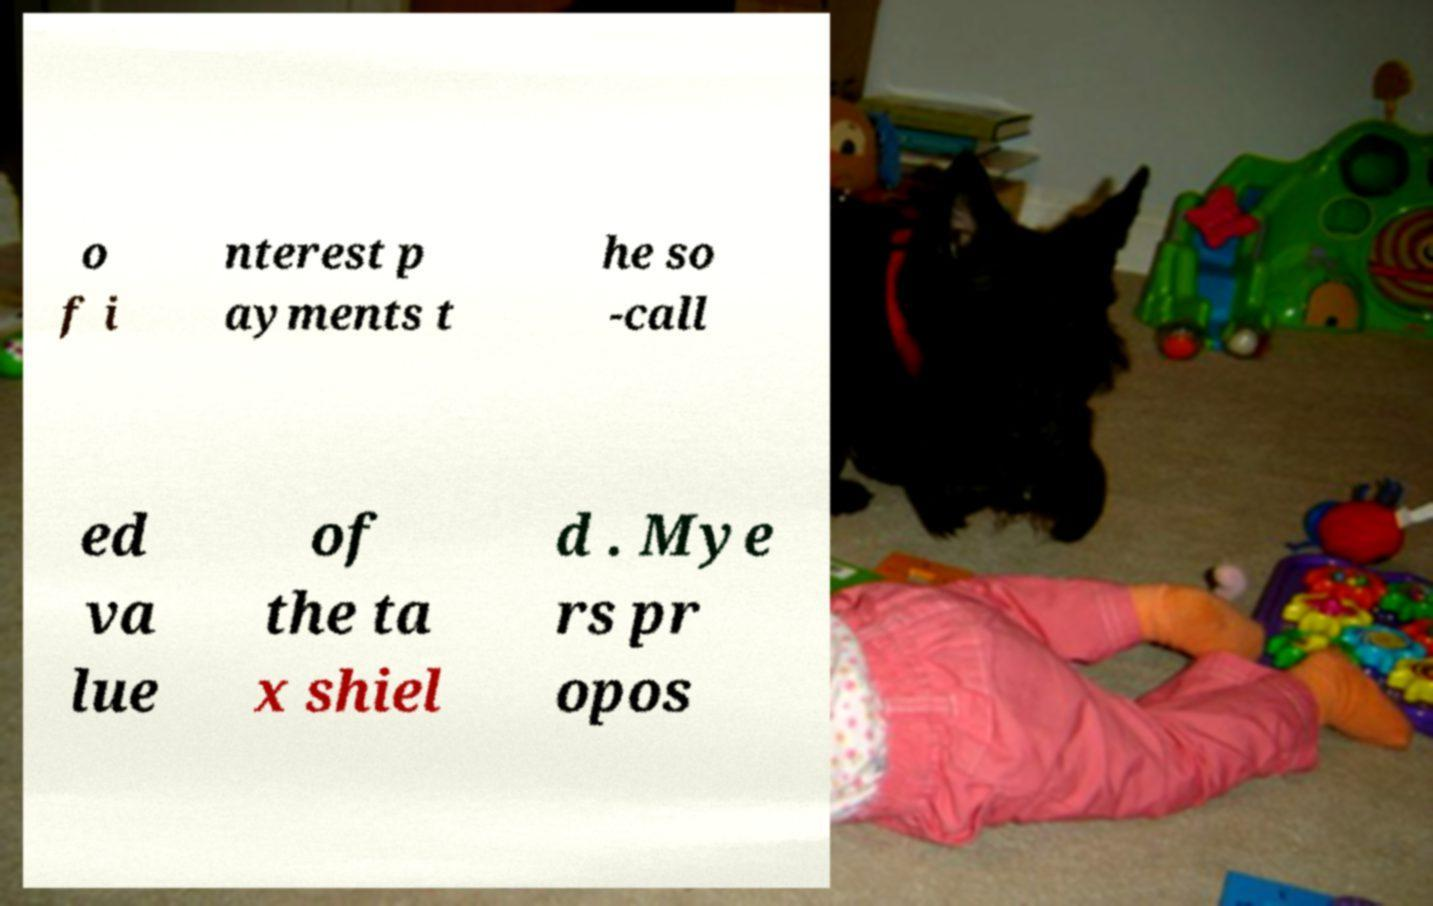I need the written content from this picture converted into text. Can you do that? o f i nterest p ayments t he so -call ed va lue of the ta x shiel d . Mye rs pr opos 